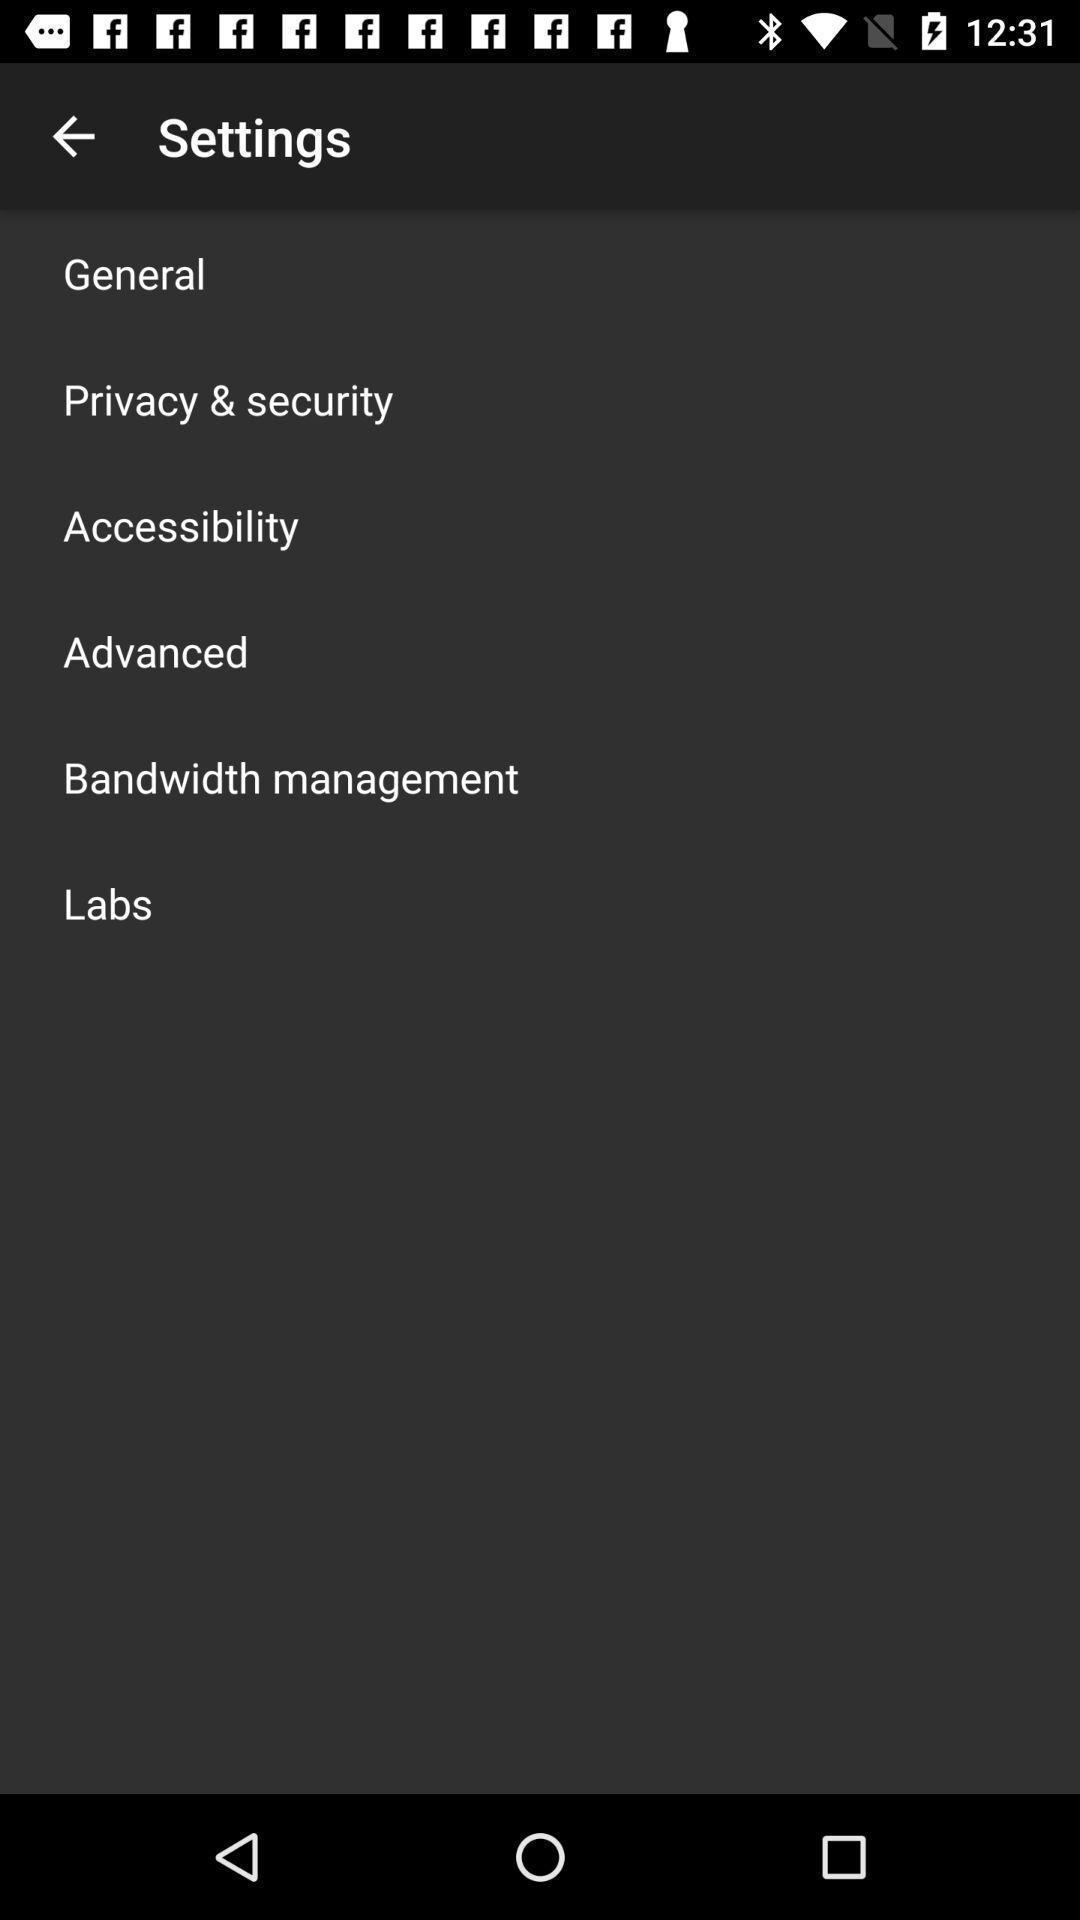What can you discern from this picture? Settings page. 